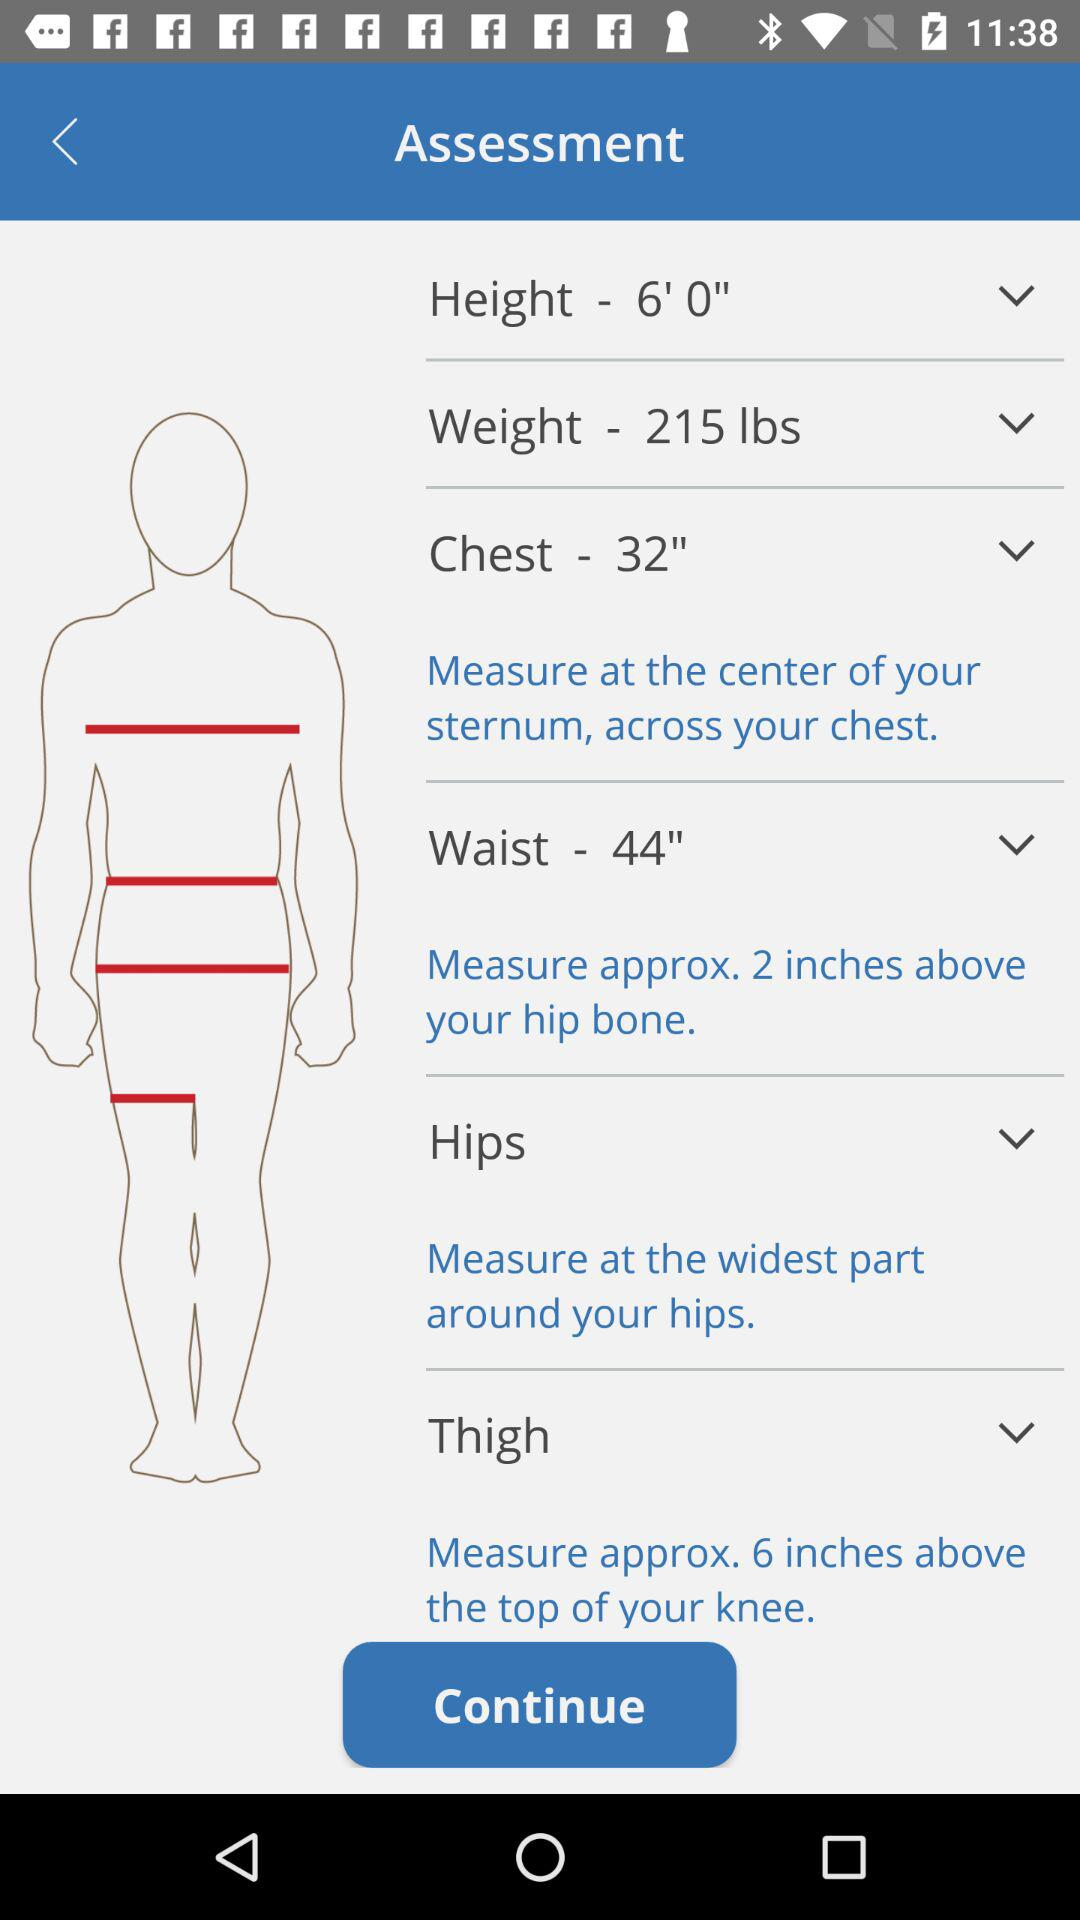How much more does the waist measurement differ from the chest measurement?
Answer the question using a single word or phrase. 12 